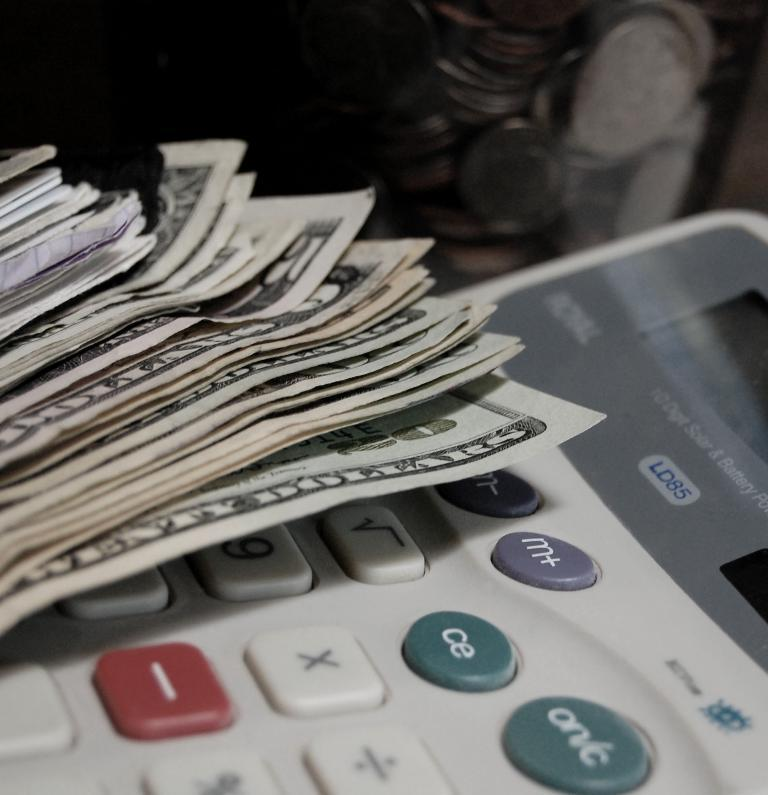<image>
Share a concise interpretation of the image provided. Man 20 dollar bills on top of a LD85 calculator. 